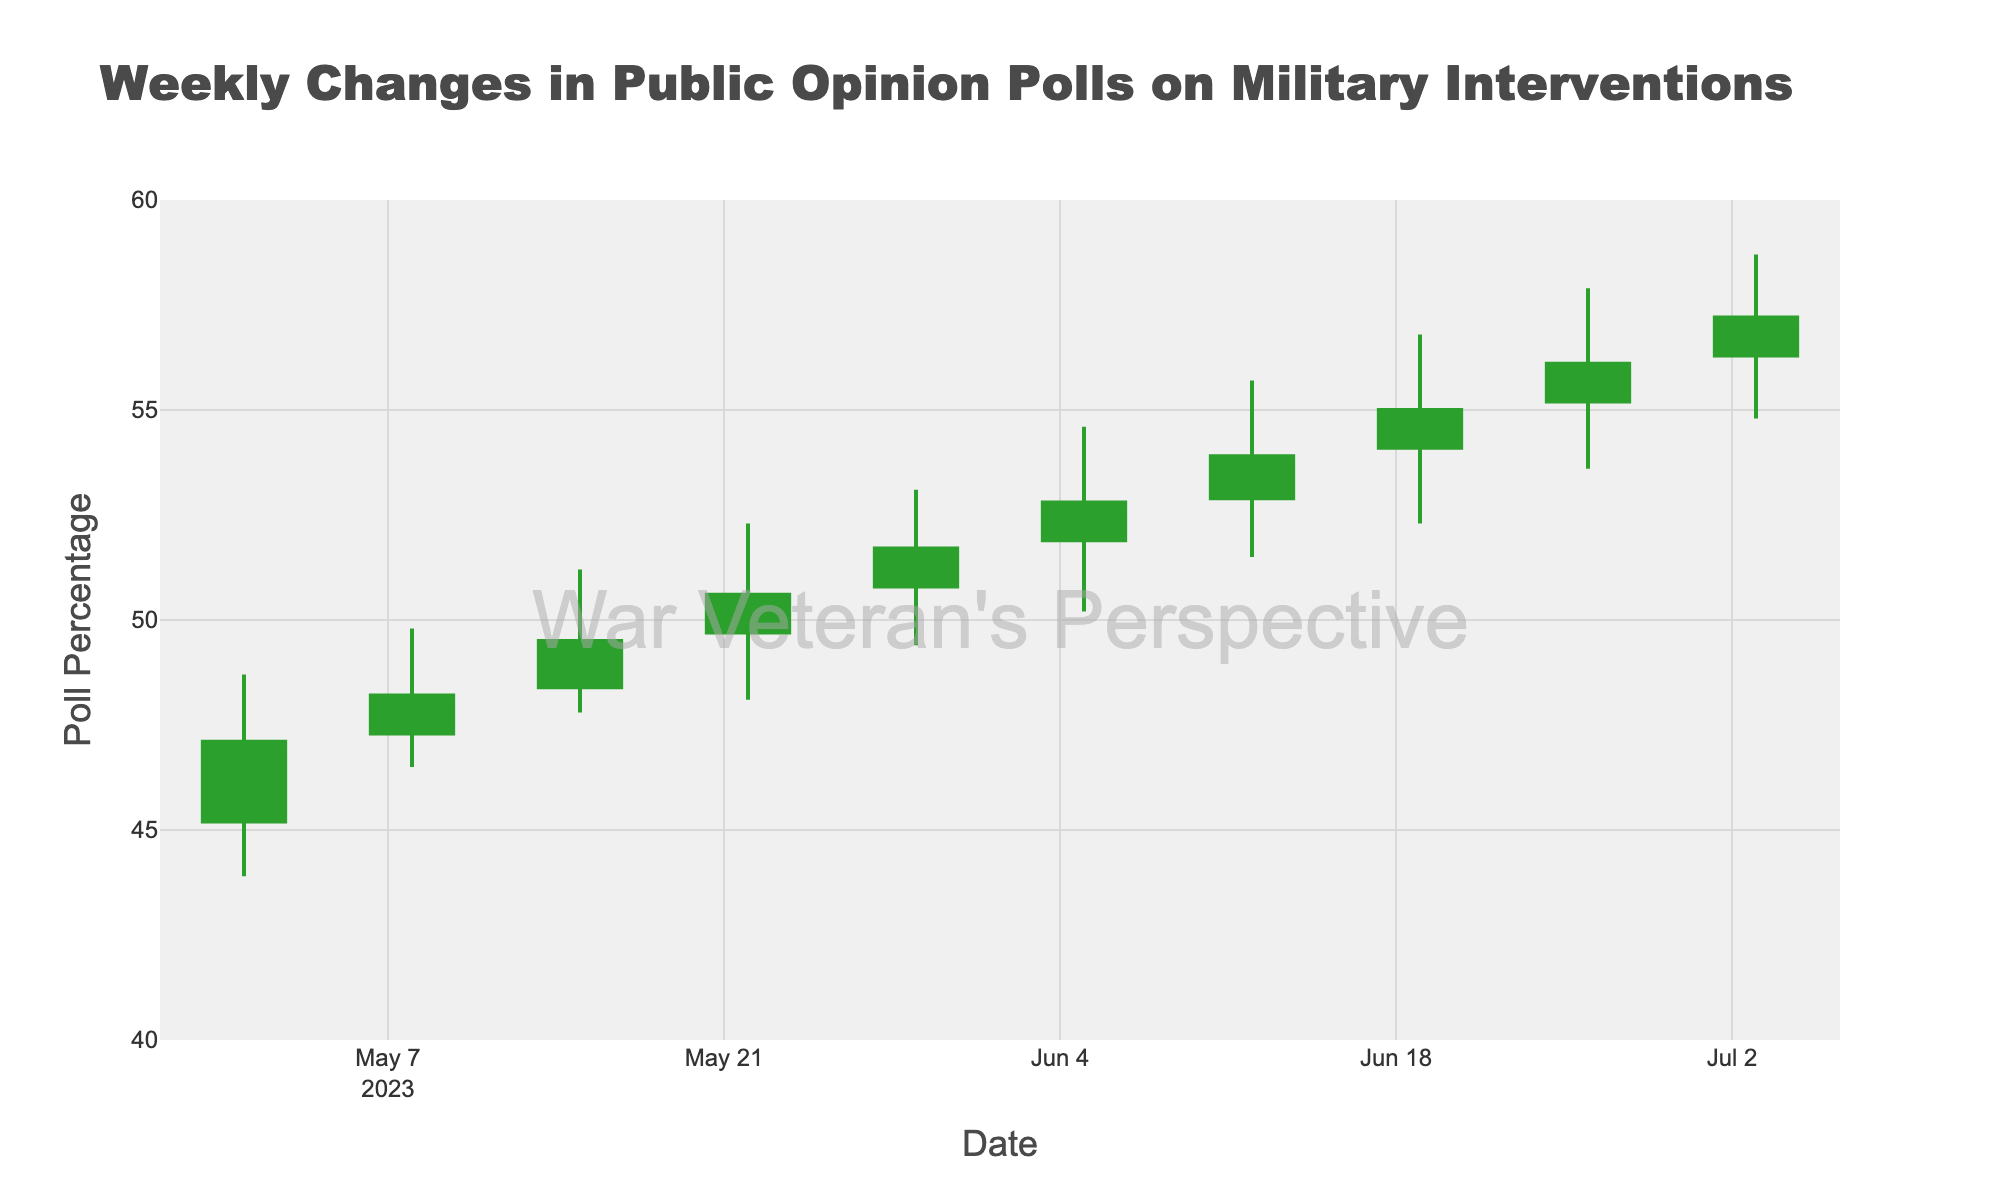What is the title of the figure? The title is displayed clearly at the top of the figure.
Answer: Weekly Changes in Public Opinion Polls on Military Interventions What is the range of dates shown on the x-axis? The dates are marked along the x-axis at the bottom of the figure, showing the weekly intervals.
Answer: From 2023-05-01 to 2023-07-03 What is the value of the highest poll percentage recorded in the figure? Identify the maximum value in the 'High' series by examining the peaks of the candlesticks.
Answer: 58.7 During which week did the poll percentage drop to its lowest point? Look for the minimum 'Low' value on the candlesticks and identify the corresponding date.
Answer: 2023-05-01 What color represents increasing poll percentages? The increasing line and fill colors are distinguishable from the candlestick colors in the chart.
Answer: Green What is the difference in the opening poll percentage between the weeks of 2023-05-01 and 2023-07-03? Subtract the opening percentage on 2023-05-01 from the opening percentage on 2023-07-03.
Answer: 56.3 - 45.2 = 11.1 During which week was the closing poll percentage exactly 49.5? Search for the 'Close' value that matches 49.5 and note the corresponding week.
Answer: 2023-05-15 How many weeks did the poll percentage close higher than the opening percentage? Count the number of candlesticks where the closing value is higher than the opening value.
Answer: 9 weeks Between which two consecutive weeks was the increase in the closing poll percentage the largest? Calculate the differences in consecutive 'Close' values and identify the largest increase.
Answer: Between 2023-06-19 and 2023-06-26 (56.1 - 55.0 = 1.1) What is the average closing poll percentage over the 10 weeks displayed? Add all 'Close' values and divide by the number of weeks (10). Detailed calculation: (47.1 + 48.2 + 49.5 + 50.6 + 51.7 + 52.8 + 53.9 + 55.0 + 56.1 + 57.2) / 10 = 52.21.
Answer: 52.21 